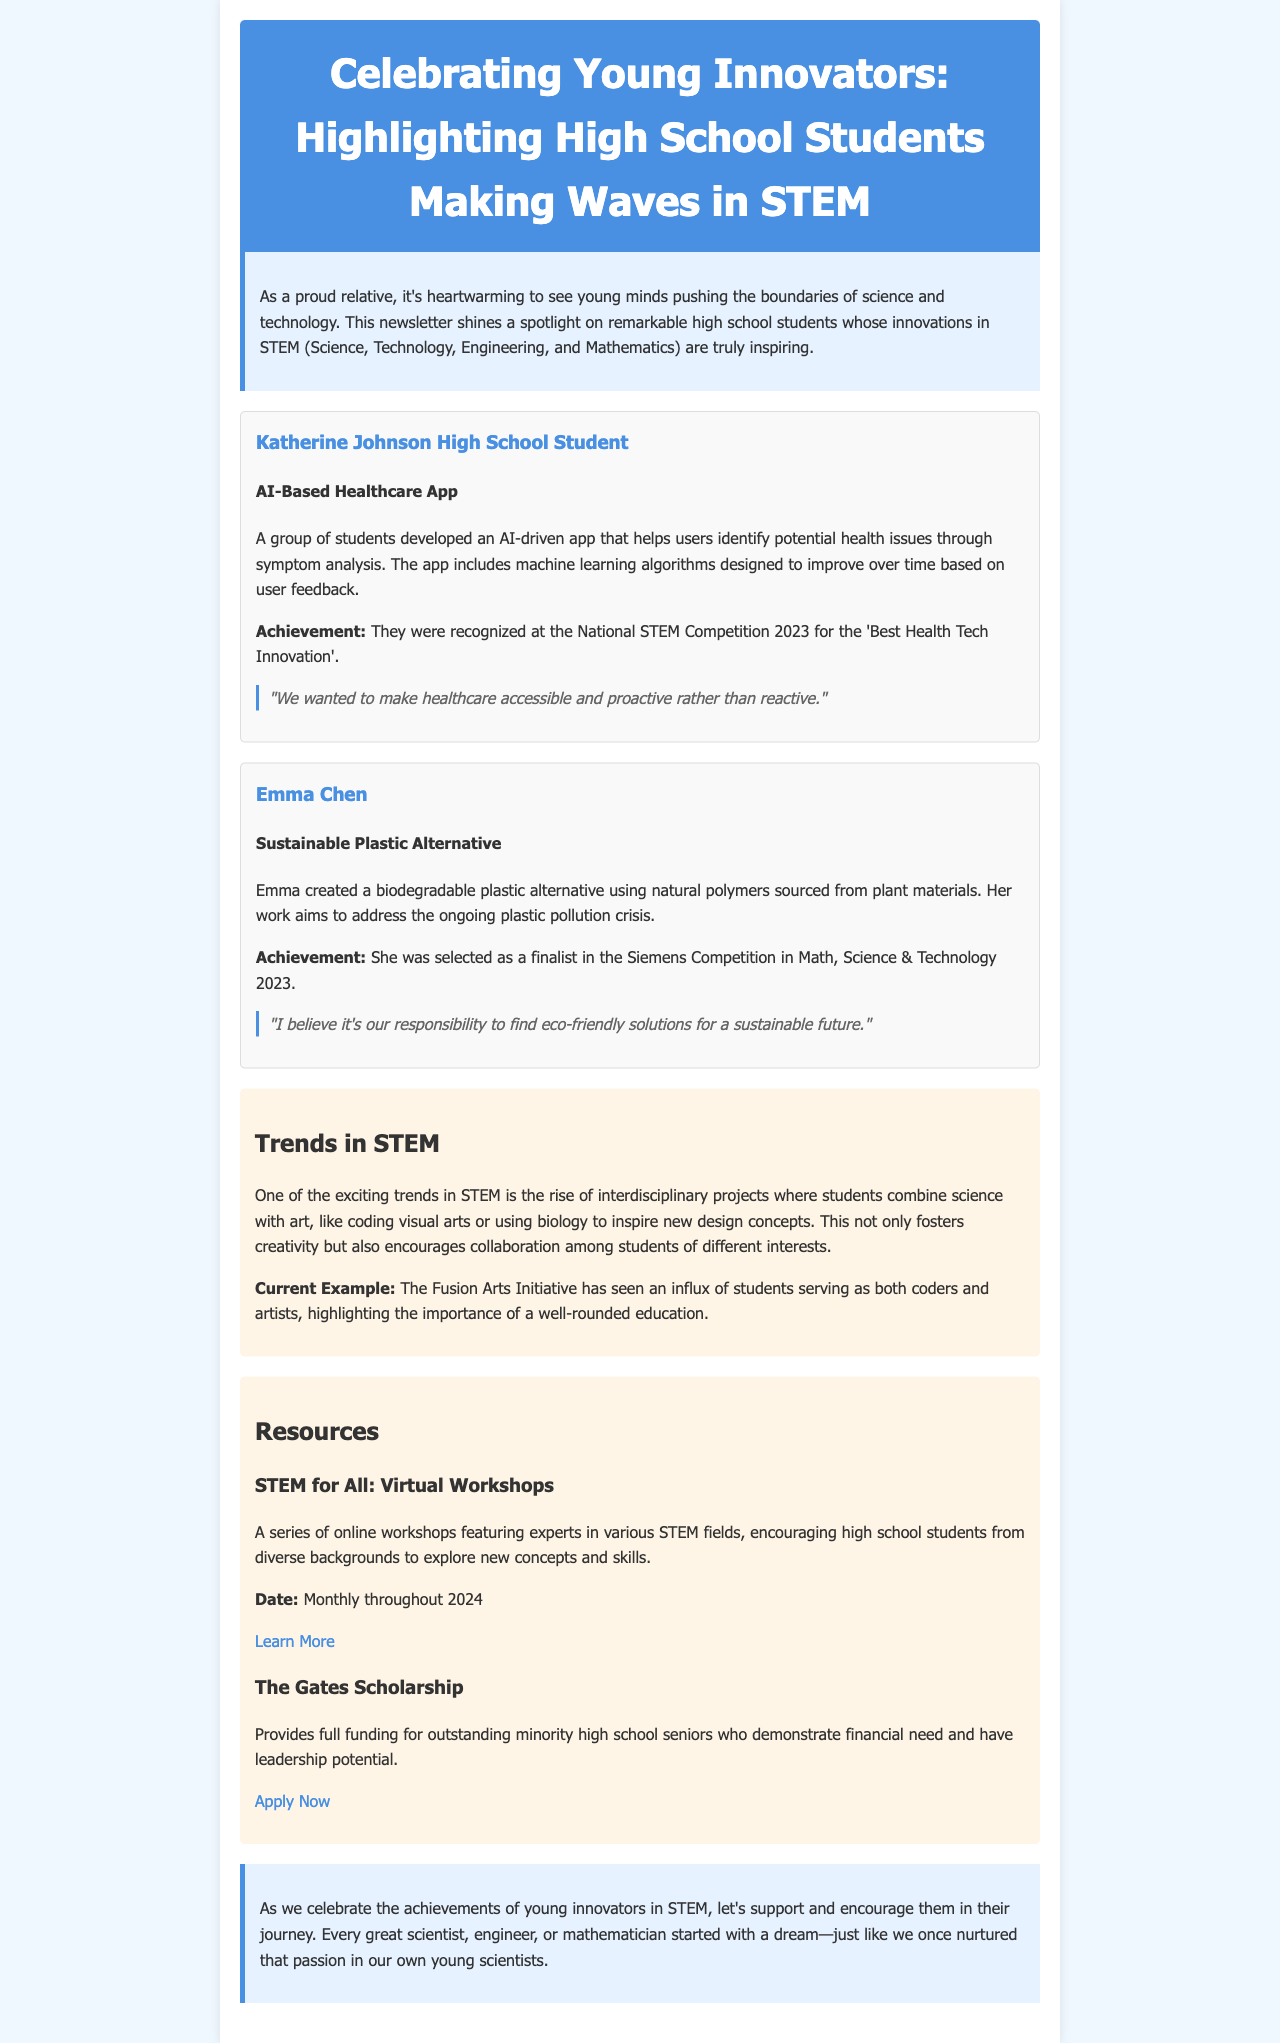what is the name of the first featured innovator? The first featured innovator is a group of students from Katherine Johnson High School who developed an AI-based healthcare app.
Answer: Katherine Johnson High School Student what is the title of Emma Chen's project? Emma Chen's project is focused on creating a biodegradable plastic alternative.
Answer: Sustainable Plastic Alternative how were the students recognized for their healthcare app? They were recognized for the 'Best Health Tech Innovation' at a national competition.
Answer: Best Health Tech Innovation what year did the Siemens Competition take place? The Siemens Competition mentioned in the document took place in 2023.
Answer: 2023 what is a current trend in STEM highlighted in the newsletter? The trend mentioned is the rise of interdisciplinary projects combining science with art.
Answer: Interdisciplinary projects how often are the "STEM for All" workshops held? The workshops are held monthly throughout 2024.
Answer: Monthly what is the purpose of The Gates Scholarship? The Gates Scholarship provides funding for outstanding minority high school seniors with financial need.
Answer: Full funding for outstanding minority high school seniors what initiative encourages creativity among students? The Fusion Arts Initiative is presented as an example encouraging creativity among students.
Answer: Fusion Arts Initiative what is the theme of the introductory section of the newsletter? The introductory section focuses on celebrating young minds making advances in STEM fields.
Answer: Celebrating young minds in STEM 